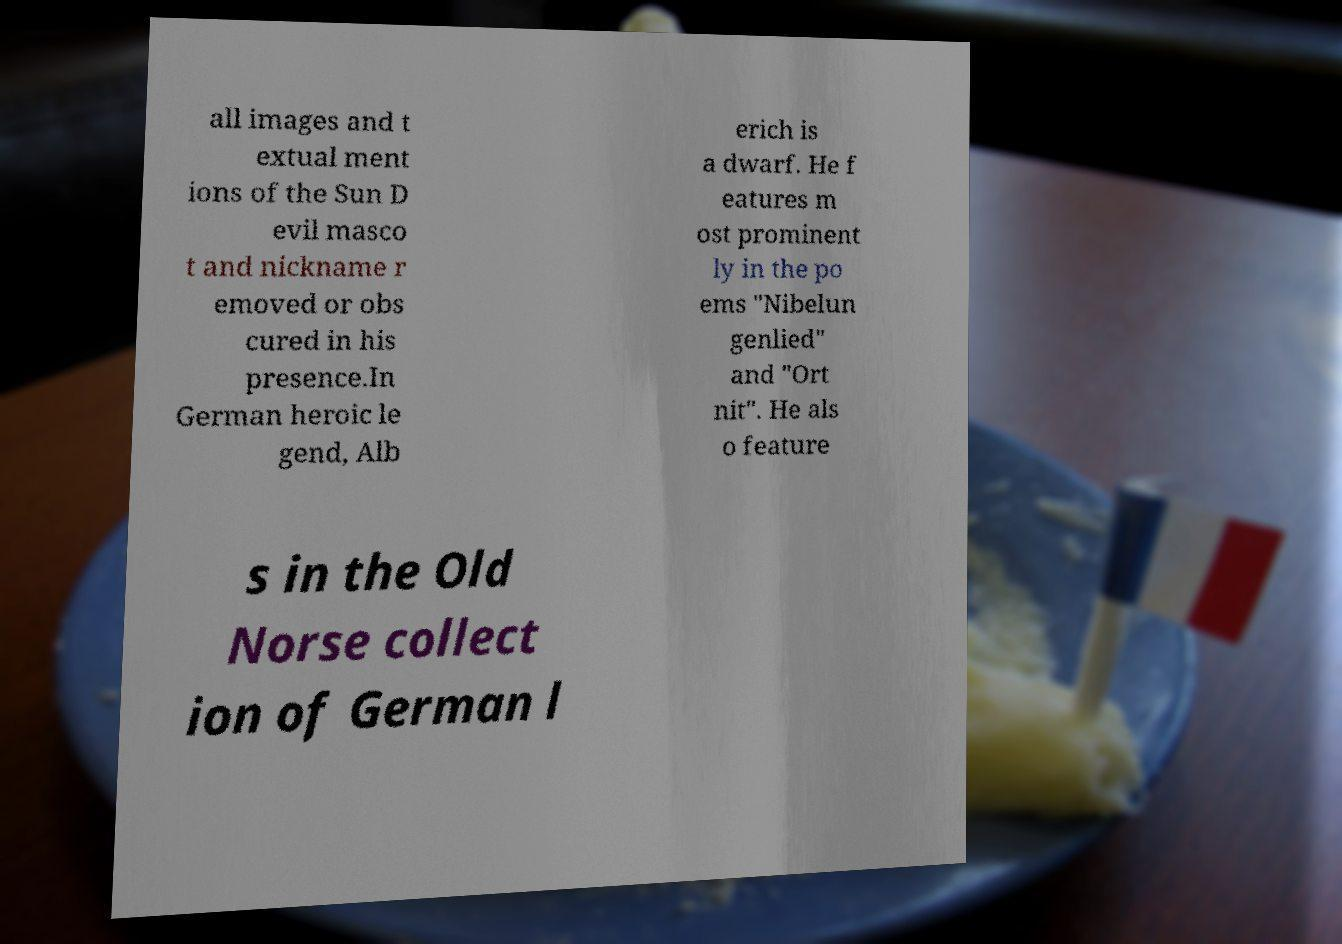There's text embedded in this image that I need extracted. Can you transcribe it verbatim? all images and t extual ment ions of the Sun D evil masco t and nickname r emoved or obs cured in his presence.In German heroic le gend, Alb erich is a dwarf. He f eatures m ost prominent ly in the po ems "Nibelun genlied" and "Ort nit". He als o feature s in the Old Norse collect ion of German l 